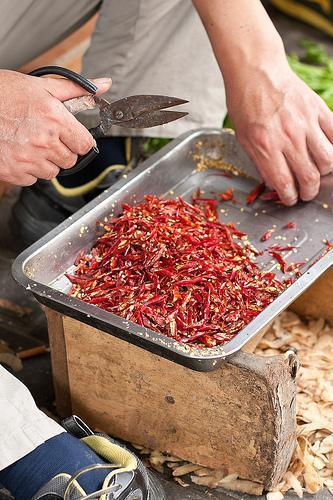How many people are in the photo?
Give a very brief answer. 1. 